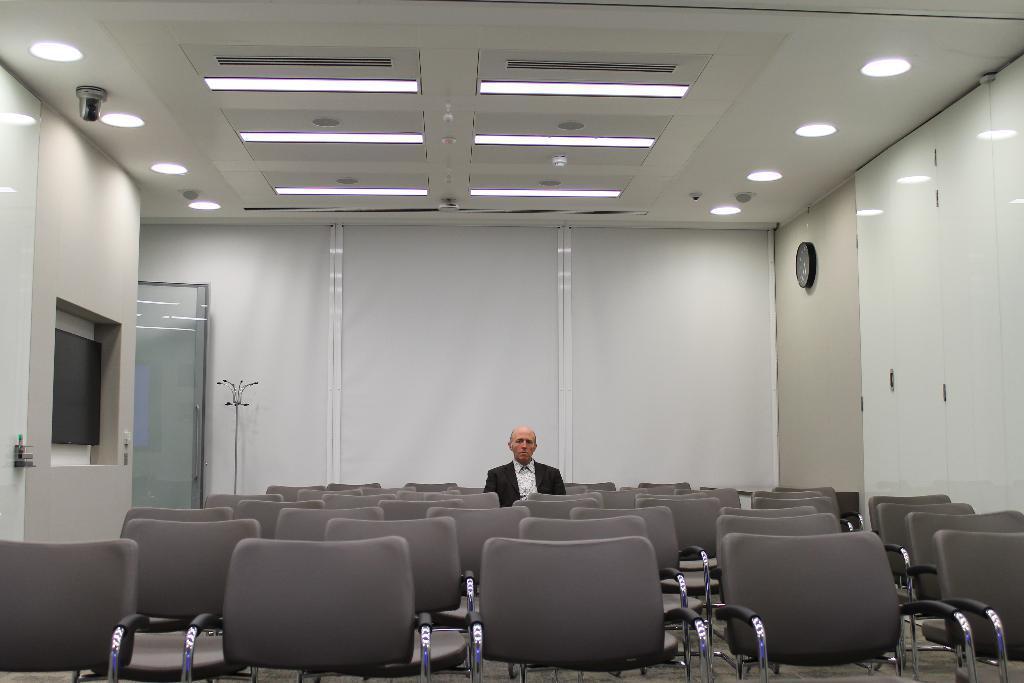In one or two sentences, can you explain what this image depicts? This is an inside view of a room. At the bottom there are many empty chairs only one person is sitting and looking at the picture. On the right side there is a clock attached to the wall. On the left side there is a door. At the top of the image I can see few lights to the roof. 